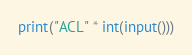<code> <loc_0><loc_0><loc_500><loc_500><_Python_>print("ACL" * int(input()))
</code> 